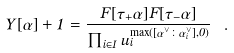Convert formula to latex. <formula><loc_0><loc_0><loc_500><loc_500>Y [ \alpha ] + 1 = \frac { F [ \tau _ { + } \alpha ] F [ \tau _ { - } \alpha ] } { \prod _ { i \in I } u _ { i } ^ { \max ( [ \alpha ^ { \vee } \colon \alpha _ { i } ^ { \vee } ] , 0 ) } } \ .</formula> 